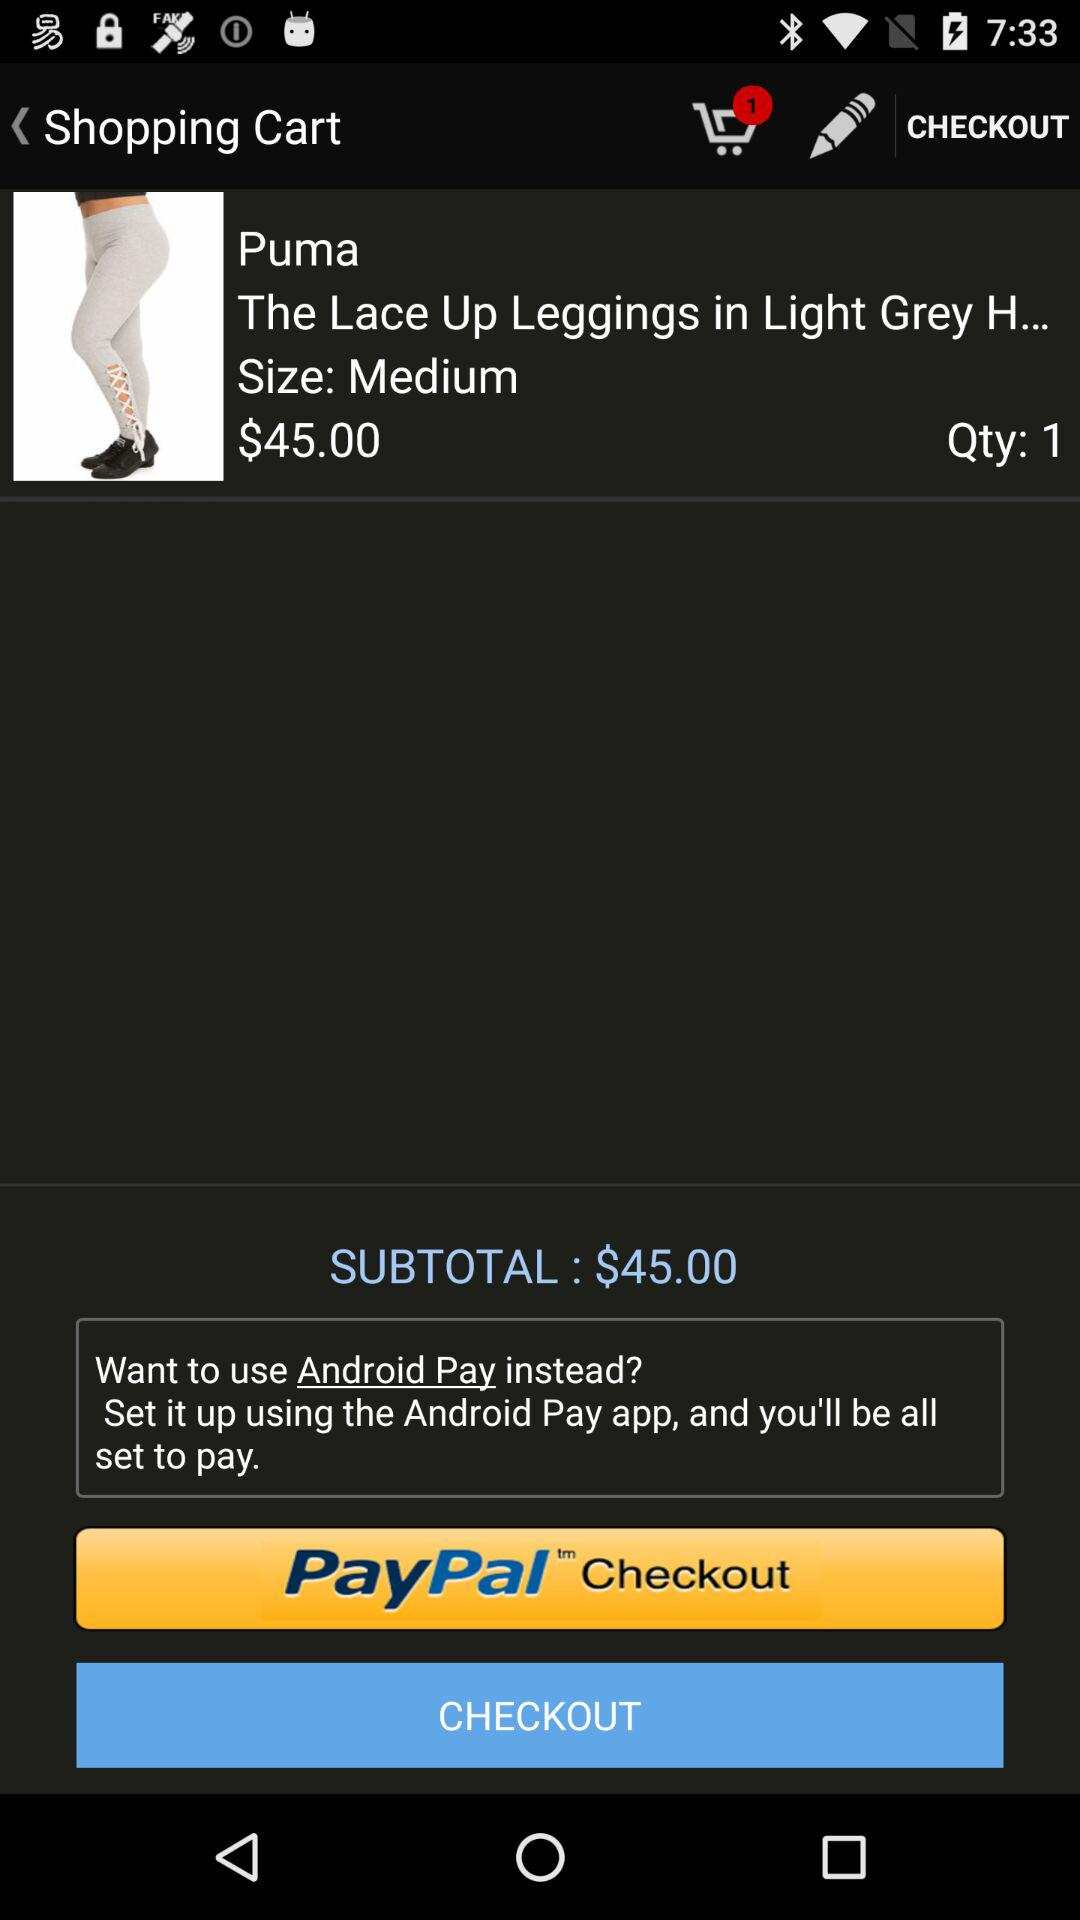How much is the subtotal of the item?
Answer the question using a single word or phrase. $45.00 